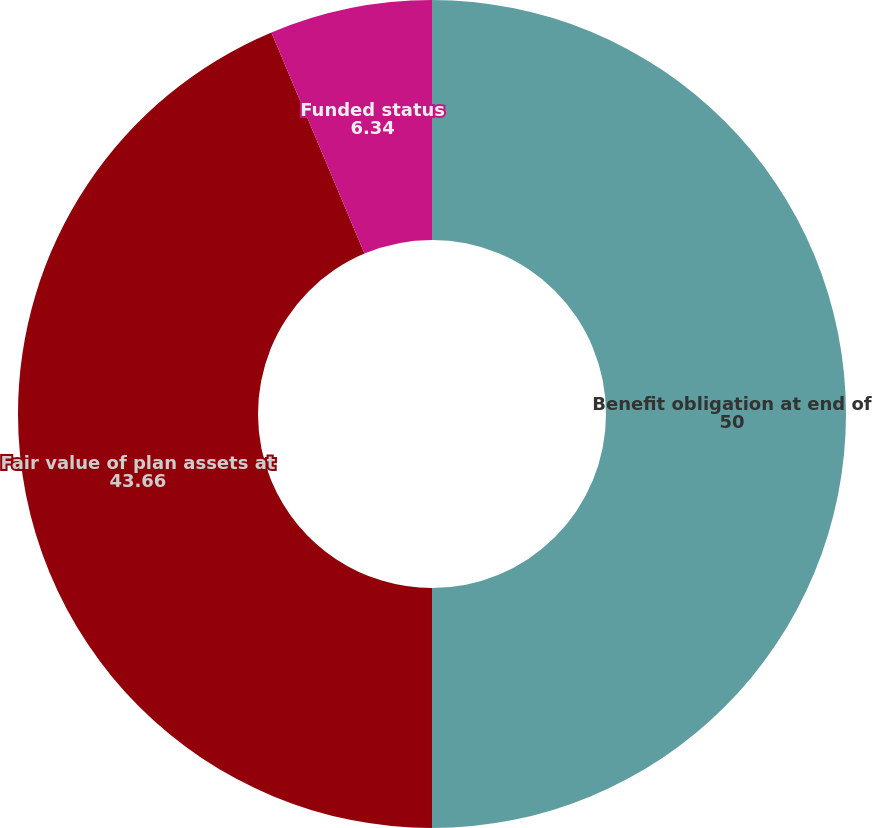<chart> <loc_0><loc_0><loc_500><loc_500><pie_chart><fcel>Benefit obligation at end of<fcel>Fair value of plan assets at<fcel>Funded status<nl><fcel>50.0%<fcel>43.66%<fcel>6.34%<nl></chart> 